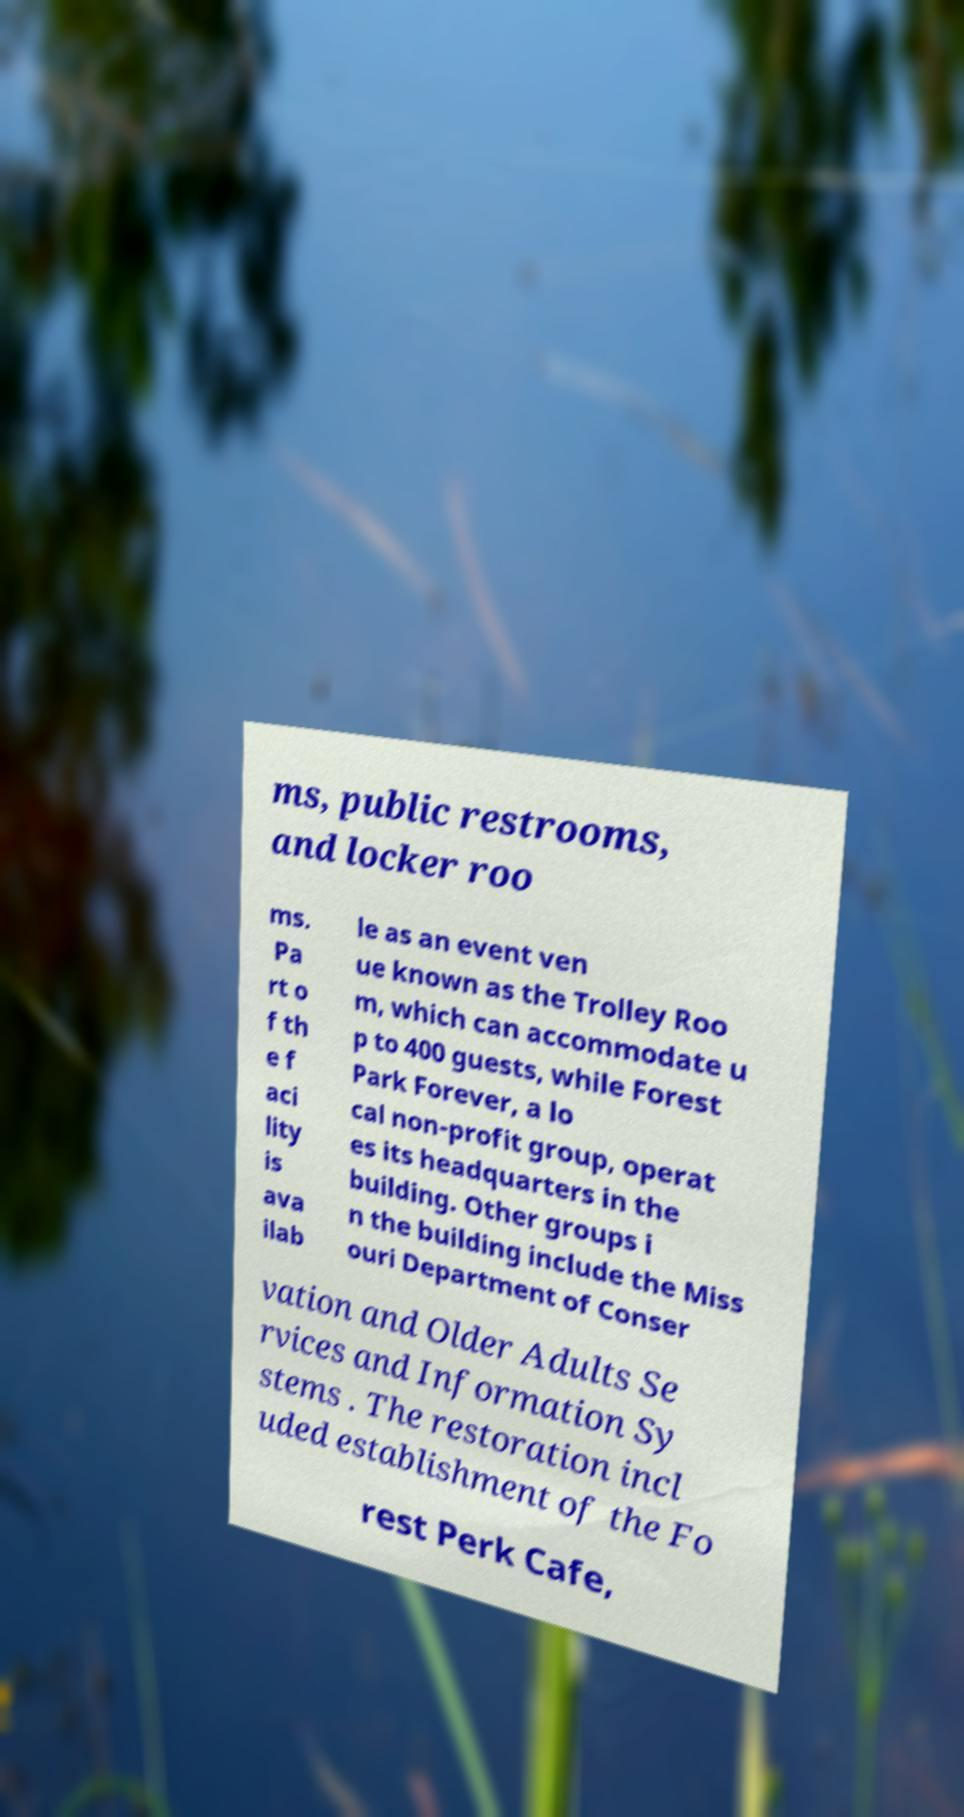For documentation purposes, I need the text within this image transcribed. Could you provide that? ms, public restrooms, and locker roo ms. Pa rt o f th e f aci lity is ava ilab le as an event ven ue known as the Trolley Roo m, which can accommodate u p to 400 guests, while Forest Park Forever, a lo cal non-profit group, operat es its headquarters in the building. Other groups i n the building include the Miss ouri Department of Conser vation and Older Adults Se rvices and Information Sy stems . The restoration incl uded establishment of the Fo rest Perk Cafe, 